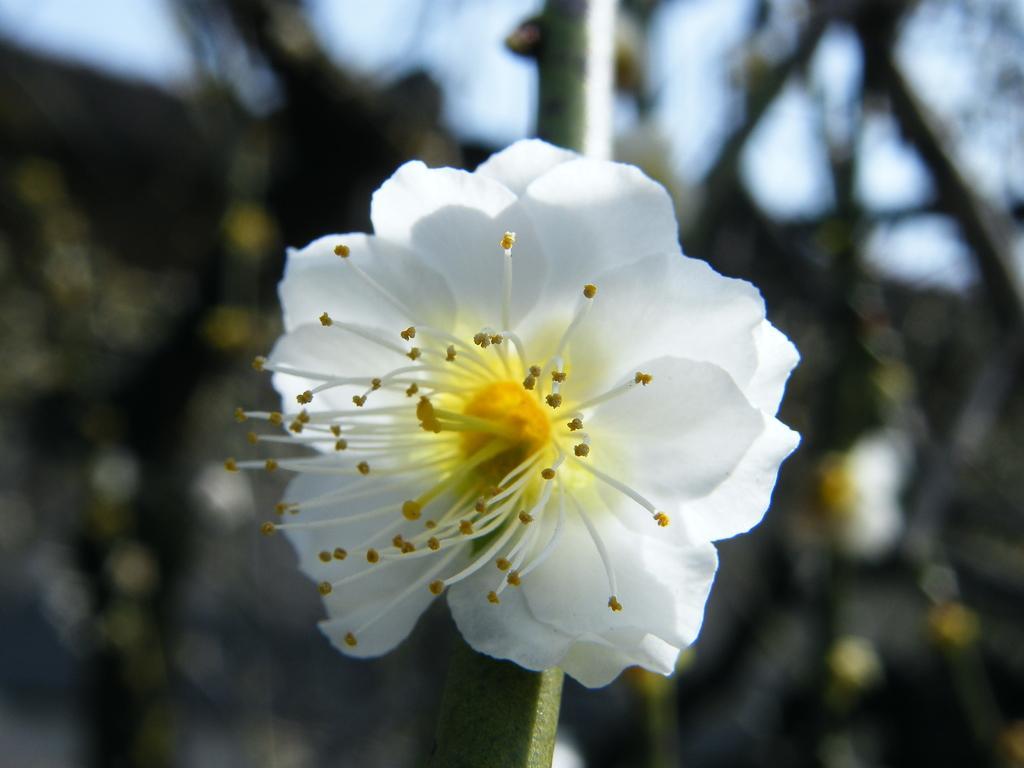In one or two sentences, can you explain what this image depicts? In the middle of the image we can see a white color flower and we can find blurry background. 